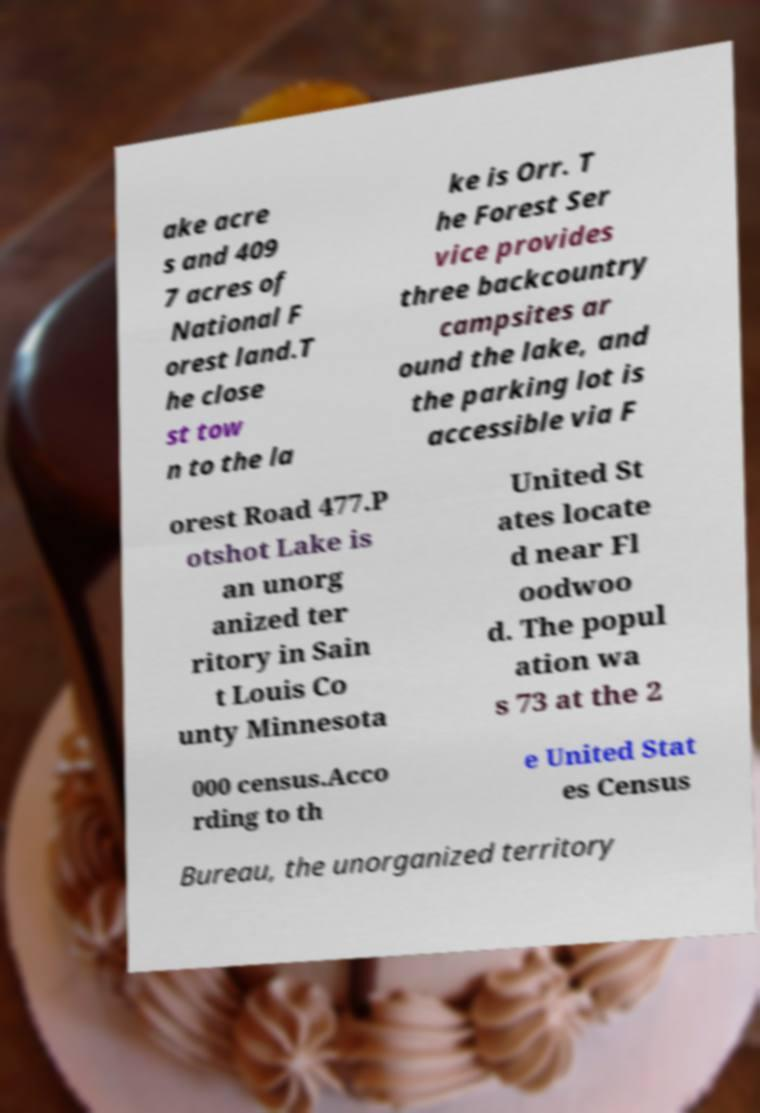I need the written content from this picture converted into text. Can you do that? ake acre s and 409 7 acres of National F orest land.T he close st tow n to the la ke is Orr. T he Forest Ser vice provides three backcountry campsites ar ound the lake, and the parking lot is accessible via F orest Road 477.P otshot Lake is an unorg anized ter ritory in Sain t Louis Co unty Minnesota United St ates locate d near Fl oodwoo d. The popul ation wa s 73 at the 2 000 census.Acco rding to th e United Stat es Census Bureau, the unorganized territory 